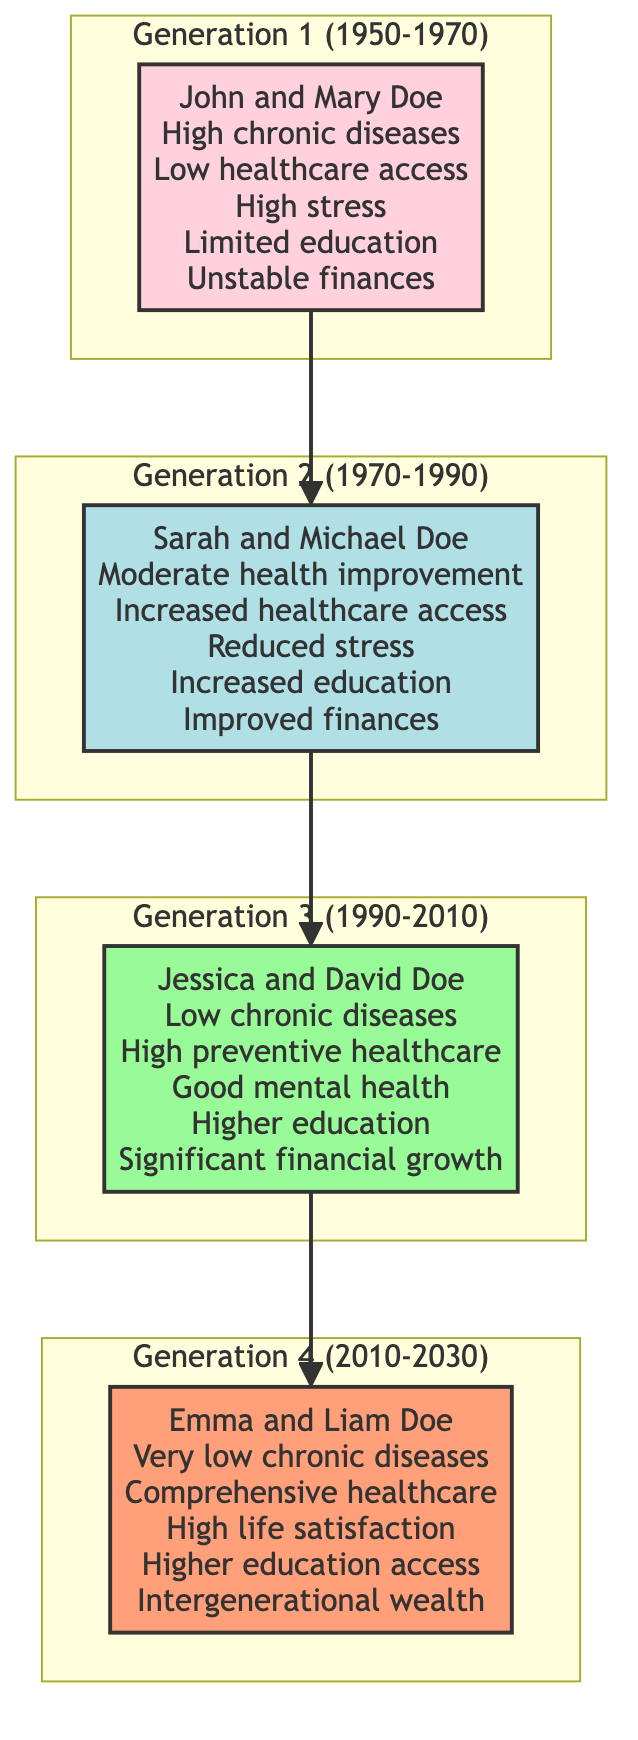What is the time period for Generation 1? Generation 1 covers the time period from 1950 to 1970, which is specified at the top of the subgraph for that generation.
Answer: 1950-1970 How many members are in Generation 2? The diagram indicates that there is one member listed in Generation 2, specifically Sarah and Michael Doe.
Answer: 1 What are the key health outcomes for Jessica and David Doe in Generation 3? The health outcomes for Jessica and David Doe are low incidences of chronic diseases, high access to preventive healthcare, and good mental health due to financial security.
Answer: Low chronic diseases, High preventive healthcare, Good mental health What is the relationship between John and Mary Doe and Sarah and Michael Doe? John and Mary Doe are the parents of Sarah and Michael Doe, as indicated by the direction of the arrows connecting the generations.
Answer: Parents What significant change occurred in health outcomes from Generation 1 to Generation 4? The health outcomes evolved from high incidences of chronic diseases and low access to healthcare in Generation 1 to very low incidences of chronic diseases and comprehensive healthcare access in Generation 4.
Answer: Very low chronic diseases, Comprehensive healthcare How did the introduction of fair labor practices (Generation 2) affect wellbeing changes compared to Generation 1? The introduction of fair labor practices led to increased educational attainment and improved financial stability in Generation 2 compared to limited educational opportunities and unstable financial conditions in Generation 1.
Answer: Increased education, Improved finances What is the economic context during Generation 3? The economic context during Generation 3, which spans from 1990 to 2010, is labeled as the "Expansion of Fair Labor Practices" in the diagram.
Answer: Expansion of Fair Labor Practices How does the financial stability of Emma and Liam Doe compare with that of John and Mary Doe? Emma and Liam Doe have intergenerational wealth accumulation and access to higher education and career opportunities, whereas John and Mary Doe faced an unstable financial condition.
Answer: Intergenerational wealth What is a common wellbeing change across all generations? Across all generations, a consistent wellbeing change is the improvement in financial conditions, as indicated by the summaries for each generation.
Answer: Improved finances 